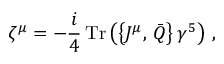<formula> <loc_0><loc_0><loc_500><loc_500>\zeta ^ { \mu } = - \frac { i } { 4 } \, T r \left ( \left \{ J ^ { \mu } , \, \bar { Q } \right \} \gamma ^ { 5 } \right ) \, ,</formula> 